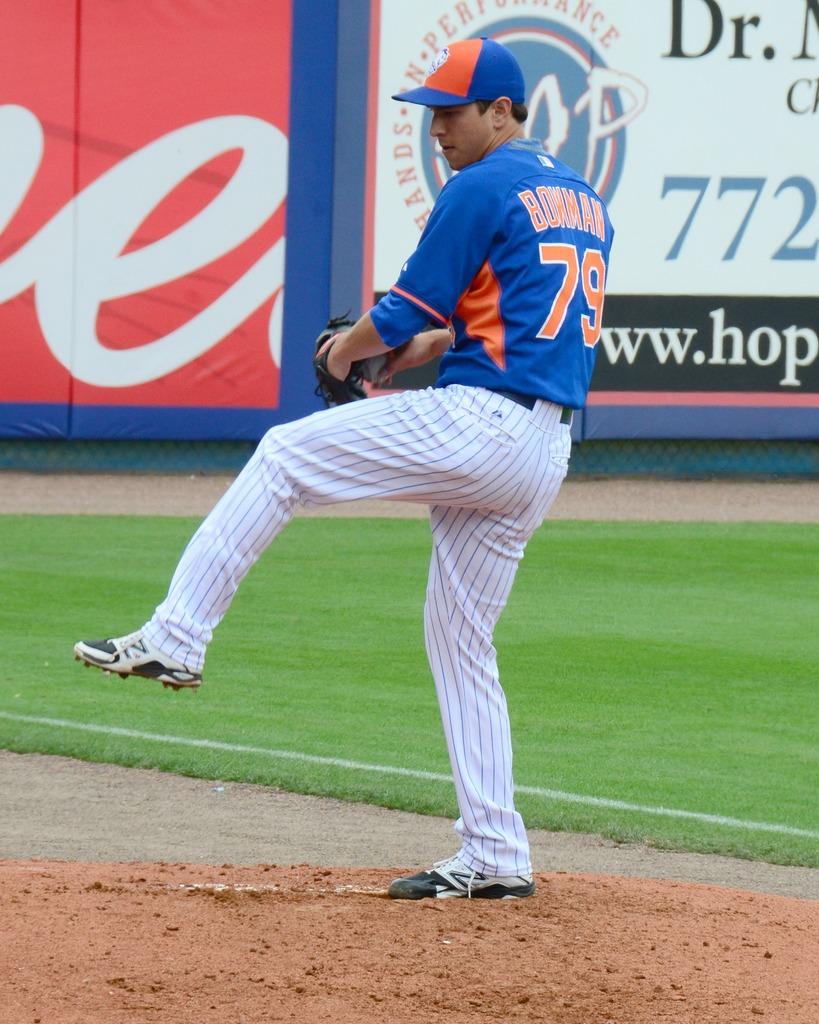What are the first three numbers on the billboard in the background?
Ensure brevity in your answer.  772. 